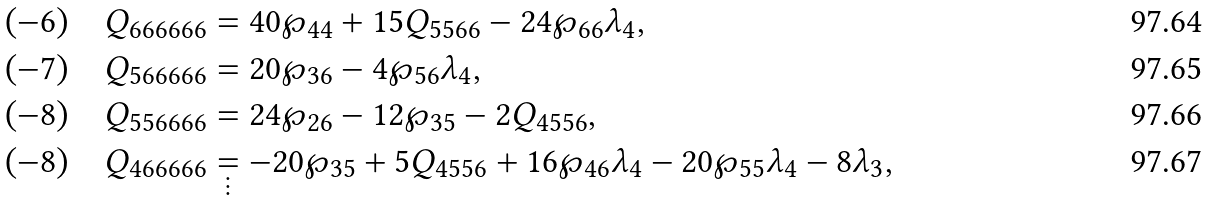Convert formula to latex. <formula><loc_0><loc_0><loc_500><loc_500>( - 6 ) \quad Q _ { 6 6 6 6 6 6 } & = 4 0 \wp _ { 4 4 } + 1 5 Q _ { 5 5 6 6 } - 2 4 \wp _ { 6 6 } \lambda _ { 4 } , \\ ( - 7 ) \quad Q _ { 5 6 6 6 6 6 } & = 2 0 \wp _ { 3 6 } - 4 \wp _ { 5 6 } \lambda _ { 4 } , \\ ( - 8 ) \quad Q _ { 5 5 6 6 6 6 } & = 2 4 \wp _ { 2 6 } - 1 2 \wp _ { 3 5 } - 2 Q _ { 4 5 5 6 } , \\ ( - 8 ) \quad Q _ { 4 6 6 6 6 6 } & \underset { \vdots } { = } - 2 0 \wp _ { 3 5 } + 5 Q _ { 4 5 5 6 } + 1 6 \wp _ { 4 6 } \lambda _ { 4 } - 2 0 \wp _ { 5 5 } \lambda _ { 4 } - 8 \lambda _ { 3 } ,</formula> 